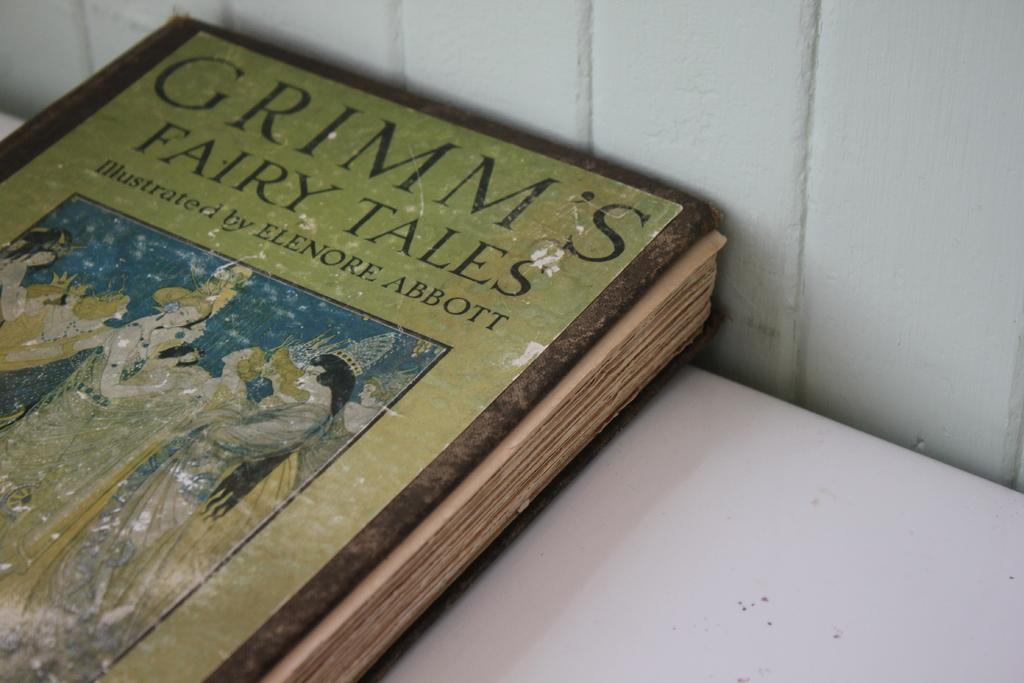<image>
Summarize the visual content of the image. A somewhat battered cover of Grimm's fairy tales. 